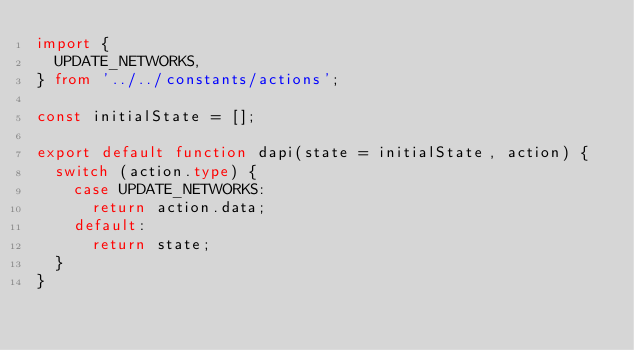<code> <loc_0><loc_0><loc_500><loc_500><_TypeScript_>import {
  UPDATE_NETWORKS,
} from '../../constants/actions';

const initialState = [];

export default function dapi(state = initialState, action) {
  switch (action.type) {
    case UPDATE_NETWORKS:
      return action.data;
    default:
      return state;
  }
}
</code> 